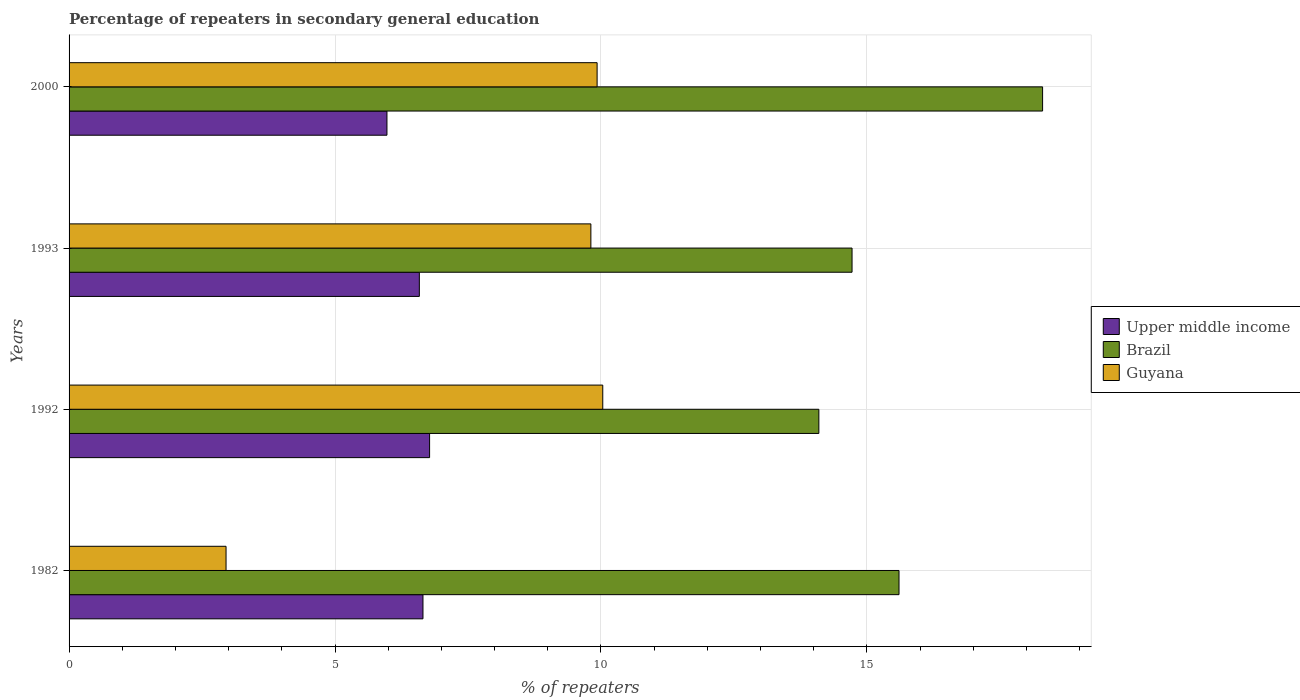Are the number of bars per tick equal to the number of legend labels?
Give a very brief answer. Yes. Are the number of bars on each tick of the Y-axis equal?
Your answer should be compact. Yes. In how many cases, is the number of bars for a given year not equal to the number of legend labels?
Your answer should be compact. 0. What is the percentage of repeaters in secondary general education in Guyana in 1982?
Make the answer very short. 2.95. Across all years, what is the maximum percentage of repeaters in secondary general education in Guyana?
Make the answer very short. 10.03. Across all years, what is the minimum percentage of repeaters in secondary general education in Upper middle income?
Your answer should be very brief. 5.98. In which year was the percentage of repeaters in secondary general education in Upper middle income maximum?
Your response must be concise. 1992. What is the total percentage of repeaters in secondary general education in Guyana in the graph?
Provide a short and direct response. 32.72. What is the difference between the percentage of repeaters in secondary general education in Upper middle income in 1992 and that in 1993?
Offer a terse response. 0.19. What is the difference between the percentage of repeaters in secondary general education in Upper middle income in 1992 and the percentage of repeaters in secondary general education in Brazil in 2000?
Provide a short and direct response. -11.53. What is the average percentage of repeaters in secondary general education in Guyana per year?
Offer a very short reply. 8.18. In the year 1993, what is the difference between the percentage of repeaters in secondary general education in Guyana and percentage of repeaters in secondary general education in Upper middle income?
Make the answer very short. 3.22. In how many years, is the percentage of repeaters in secondary general education in Guyana greater than 12 %?
Offer a very short reply. 0. What is the ratio of the percentage of repeaters in secondary general education in Upper middle income in 1982 to that in 2000?
Your response must be concise. 1.11. Is the percentage of repeaters in secondary general education in Upper middle income in 1982 less than that in 1993?
Your answer should be compact. No. What is the difference between the highest and the second highest percentage of repeaters in secondary general education in Upper middle income?
Offer a very short reply. 0.12. What is the difference between the highest and the lowest percentage of repeaters in secondary general education in Guyana?
Your answer should be compact. 7.08. What does the 3rd bar from the top in 1992 represents?
Offer a terse response. Upper middle income. What does the 3rd bar from the bottom in 2000 represents?
Make the answer very short. Guyana. Are all the bars in the graph horizontal?
Offer a very short reply. Yes. How many years are there in the graph?
Your response must be concise. 4. What is the difference between two consecutive major ticks on the X-axis?
Provide a succinct answer. 5. Where does the legend appear in the graph?
Ensure brevity in your answer.  Center right. How are the legend labels stacked?
Offer a terse response. Vertical. What is the title of the graph?
Your answer should be compact. Percentage of repeaters in secondary general education. Does "Zambia" appear as one of the legend labels in the graph?
Offer a very short reply. No. What is the label or title of the X-axis?
Ensure brevity in your answer.  % of repeaters. What is the % of repeaters in Upper middle income in 1982?
Ensure brevity in your answer.  6.65. What is the % of repeaters in Brazil in 1982?
Your answer should be compact. 15.6. What is the % of repeaters of Guyana in 1982?
Your answer should be very brief. 2.95. What is the % of repeaters in Upper middle income in 1992?
Provide a succinct answer. 6.78. What is the % of repeaters in Brazil in 1992?
Provide a succinct answer. 14.1. What is the % of repeaters of Guyana in 1992?
Your response must be concise. 10.03. What is the % of repeaters of Upper middle income in 1993?
Provide a short and direct response. 6.59. What is the % of repeaters of Brazil in 1993?
Offer a very short reply. 14.72. What is the % of repeaters of Guyana in 1993?
Keep it short and to the point. 9.81. What is the % of repeaters of Upper middle income in 2000?
Your answer should be very brief. 5.98. What is the % of repeaters of Brazil in 2000?
Your answer should be very brief. 18.3. What is the % of repeaters in Guyana in 2000?
Provide a succinct answer. 9.93. Across all years, what is the maximum % of repeaters in Upper middle income?
Make the answer very short. 6.78. Across all years, what is the maximum % of repeaters of Brazil?
Provide a succinct answer. 18.3. Across all years, what is the maximum % of repeaters in Guyana?
Give a very brief answer. 10.03. Across all years, what is the minimum % of repeaters of Upper middle income?
Keep it short and to the point. 5.98. Across all years, what is the minimum % of repeaters in Brazil?
Offer a terse response. 14.1. Across all years, what is the minimum % of repeaters in Guyana?
Make the answer very short. 2.95. What is the total % of repeaters of Upper middle income in the graph?
Provide a short and direct response. 25.99. What is the total % of repeaters of Brazil in the graph?
Keep it short and to the point. 62.73. What is the total % of repeaters in Guyana in the graph?
Offer a very short reply. 32.72. What is the difference between the % of repeaters in Upper middle income in 1982 and that in 1992?
Offer a very short reply. -0.12. What is the difference between the % of repeaters of Brazil in 1982 and that in 1992?
Provide a short and direct response. 1.51. What is the difference between the % of repeaters in Guyana in 1982 and that in 1992?
Your response must be concise. -7.08. What is the difference between the % of repeaters of Upper middle income in 1982 and that in 1993?
Offer a very short reply. 0.07. What is the difference between the % of repeaters of Brazil in 1982 and that in 1993?
Provide a succinct answer. 0.88. What is the difference between the % of repeaters of Guyana in 1982 and that in 1993?
Give a very brief answer. -6.86. What is the difference between the % of repeaters in Upper middle income in 1982 and that in 2000?
Provide a succinct answer. 0.68. What is the difference between the % of repeaters in Brazil in 1982 and that in 2000?
Offer a very short reply. -2.7. What is the difference between the % of repeaters of Guyana in 1982 and that in 2000?
Keep it short and to the point. -6.98. What is the difference between the % of repeaters in Upper middle income in 1992 and that in 1993?
Your answer should be compact. 0.19. What is the difference between the % of repeaters of Brazil in 1992 and that in 1993?
Provide a succinct answer. -0.62. What is the difference between the % of repeaters of Guyana in 1992 and that in 1993?
Offer a very short reply. 0.22. What is the difference between the % of repeaters of Upper middle income in 1992 and that in 2000?
Give a very brief answer. 0.8. What is the difference between the % of repeaters of Brazil in 1992 and that in 2000?
Offer a terse response. -4.21. What is the difference between the % of repeaters in Guyana in 1992 and that in 2000?
Your answer should be compact. 0.11. What is the difference between the % of repeaters in Upper middle income in 1993 and that in 2000?
Make the answer very short. 0.61. What is the difference between the % of repeaters of Brazil in 1993 and that in 2000?
Offer a very short reply. -3.58. What is the difference between the % of repeaters of Guyana in 1993 and that in 2000?
Your answer should be compact. -0.12. What is the difference between the % of repeaters in Upper middle income in 1982 and the % of repeaters in Brazil in 1992?
Provide a succinct answer. -7.44. What is the difference between the % of repeaters in Upper middle income in 1982 and the % of repeaters in Guyana in 1992?
Your response must be concise. -3.38. What is the difference between the % of repeaters in Brazil in 1982 and the % of repeaters in Guyana in 1992?
Offer a terse response. 5.57. What is the difference between the % of repeaters in Upper middle income in 1982 and the % of repeaters in Brazil in 1993?
Give a very brief answer. -8.07. What is the difference between the % of repeaters of Upper middle income in 1982 and the % of repeaters of Guyana in 1993?
Ensure brevity in your answer.  -3.16. What is the difference between the % of repeaters in Brazil in 1982 and the % of repeaters in Guyana in 1993?
Provide a succinct answer. 5.79. What is the difference between the % of repeaters in Upper middle income in 1982 and the % of repeaters in Brazil in 2000?
Your response must be concise. -11.65. What is the difference between the % of repeaters of Upper middle income in 1982 and the % of repeaters of Guyana in 2000?
Make the answer very short. -3.27. What is the difference between the % of repeaters in Brazil in 1982 and the % of repeaters in Guyana in 2000?
Provide a short and direct response. 5.68. What is the difference between the % of repeaters in Upper middle income in 1992 and the % of repeaters in Brazil in 1993?
Offer a terse response. -7.94. What is the difference between the % of repeaters in Upper middle income in 1992 and the % of repeaters in Guyana in 1993?
Provide a succinct answer. -3.03. What is the difference between the % of repeaters in Brazil in 1992 and the % of repeaters in Guyana in 1993?
Offer a terse response. 4.29. What is the difference between the % of repeaters of Upper middle income in 1992 and the % of repeaters of Brazil in 2000?
Provide a succinct answer. -11.53. What is the difference between the % of repeaters in Upper middle income in 1992 and the % of repeaters in Guyana in 2000?
Your answer should be compact. -3.15. What is the difference between the % of repeaters of Brazil in 1992 and the % of repeaters of Guyana in 2000?
Offer a very short reply. 4.17. What is the difference between the % of repeaters in Upper middle income in 1993 and the % of repeaters in Brazil in 2000?
Offer a very short reply. -11.72. What is the difference between the % of repeaters of Upper middle income in 1993 and the % of repeaters of Guyana in 2000?
Your answer should be compact. -3.34. What is the difference between the % of repeaters in Brazil in 1993 and the % of repeaters in Guyana in 2000?
Your answer should be very brief. 4.79. What is the average % of repeaters of Upper middle income per year?
Your response must be concise. 6.5. What is the average % of repeaters of Brazil per year?
Make the answer very short. 15.68. What is the average % of repeaters in Guyana per year?
Keep it short and to the point. 8.18. In the year 1982, what is the difference between the % of repeaters in Upper middle income and % of repeaters in Brazil?
Make the answer very short. -8.95. In the year 1982, what is the difference between the % of repeaters of Upper middle income and % of repeaters of Guyana?
Your answer should be very brief. 3.7. In the year 1982, what is the difference between the % of repeaters of Brazil and % of repeaters of Guyana?
Your answer should be very brief. 12.65. In the year 1992, what is the difference between the % of repeaters of Upper middle income and % of repeaters of Brazil?
Your answer should be very brief. -7.32. In the year 1992, what is the difference between the % of repeaters in Upper middle income and % of repeaters in Guyana?
Provide a succinct answer. -3.26. In the year 1992, what is the difference between the % of repeaters in Brazil and % of repeaters in Guyana?
Ensure brevity in your answer.  4.06. In the year 1993, what is the difference between the % of repeaters of Upper middle income and % of repeaters of Brazil?
Keep it short and to the point. -8.14. In the year 1993, what is the difference between the % of repeaters of Upper middle income and % of repeaters of Guyana?
Your answer should be compact. -3.22. In the year 1993, what is the difference between the % of repeaters in Brazil and % of repeaters in Guyana?
Your answer should be compact. 4.91. In the year 2000, what is the difference between the % of repeaters in Upper middle income and % of repeaters in Brazil?
Offer a very short reply. -12.33. In the year 2000, what is the difference between the % of repeaters in Upper middle income and % of repeaters in Guyana?
Your answer should be compact. -3.95. In the year 2000, what is the difference between the % of repeaters of Brazil and % of repeaters of Guyana?
Offer a very short reply. 8.38. What is the ratio of the % of repeaters of Upper middle income in 1982 to that in 1992?
Provide a short and direct response. 0.98. What is the ratio of the % of repeaters in Brazil in 1982 to that in 1992?
Your answer should be compact. 1.11. What is the ratio of the % of repeaters in Guyana in 1982 to that in 1992?
Your response must be concise. 0.29. What is the ratio of the % of repeaters of Upper middle income in 1982 to that in 1993?
Your answer should be very brief. 1.01. What is the ratio of the % of repeaters in Brazil in 1982 to that in 1993?
Your response must be concise. 1.06. What is the ratio of the % of repeaters of Guyana in 1982 to that in 1993?
Provide a succinct answer. 0.3. What is the ratio of the % of repeaters of Upper middle income in 1982 to that in 2000?
Ensure brevity in your answer.  1.11. What is the ratio of the % of repeaters in Brazil in 1982 to that in 2000?
Your answer should be very brief. 0.85. What is the ratio of the % of repeaters in Guyana in 1982 to that in 2000?
Keep it short and to the point. 0.3. What is the ratio of the % of repeaters in Upper middle income in 1992 to that in 1993?
Offer a very short reply. 1.03. What is the ratio of the % of repeaters in Brazil in 1992 to that in 1993?
Your response must be concise. 0.96. What is the ratio of the % of repeaters in Guyana in 1992 to that in 1993?
Your answer should be very brief. 1.02. What is the ratio of the % of repeaters in Upper middle income in 1992 to that in 2000?
Ensure brevity in your answer.  1.13. What is the ratio of the % of repeaters of Brazil in 1992 to that in 2000?
Your answer should be compact. 0.77. What is the ratio of the % of repeaters of Guyana in 1992 to that in 2000?
Make the answer very short. 1.01. What is the ratio of the % of repeaters of Upper middle income in 1993 to that in 2000?
Make the answer very short. 1.1. What is the ratio of the % of repeaters in Brazil in 1993 to that in 2000?
Keep it short and to the point. 0.8. What is the ratio of the % of repeaters in Guyana in 1993 to that in 2000?
Provide a short and direct response. 0.99. What is the difference between the highest and the second highest % of repeaters of Upper middle income?
Your answer should be compact. 0.12. What is the difference between the highest and the second highest % of repeaters of Brazil?
Ensure brevity in your answer.  2.7. What is the difference between the highest and the second highest % of repeaters in Guyana?
Your answer should be compact. 0.11. What is the difference between the highest and the lowest % of repeaters of Upper middle income?
Give a very brief answer. 0.8. What is the difference between the highest and the lowest % of repeaters in Brazil?
Your answer should be very brief. 4.21. What is the difference between the highest and the lowest % of repeaters in Guyana?
Your response must be concise. 7.08. 